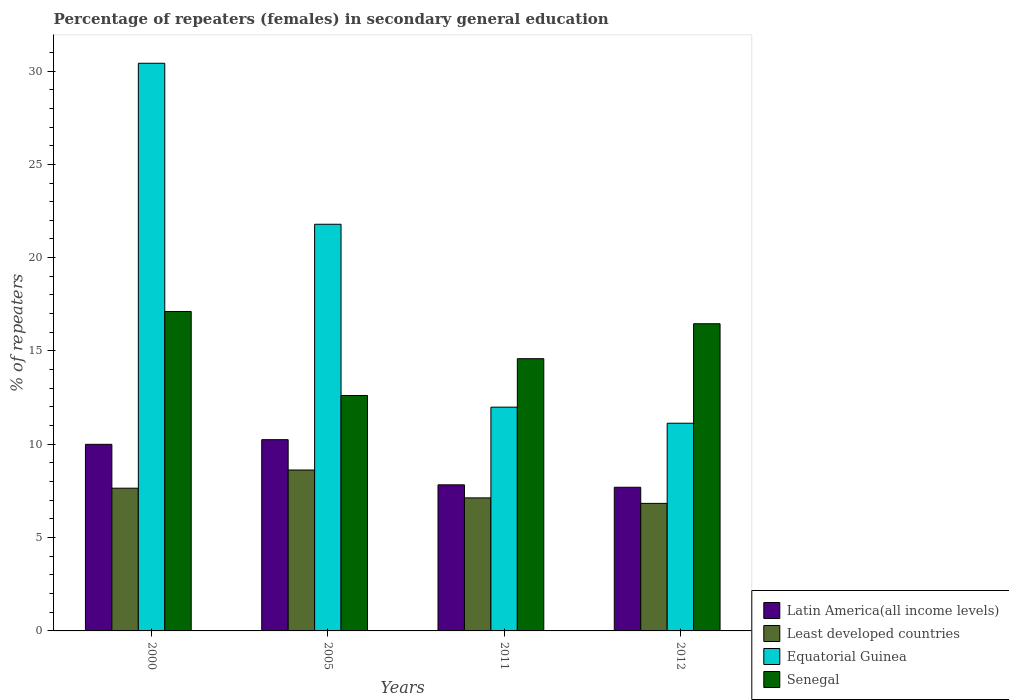How many different coloured bars are there?
Provide a succinct answer. 4. How many groups of bars are there?
Offer a terse response. 4. Are the number of bars per tick equal to the number of legend labels?
Provide a succinct answer. Yes. How many bars are there on the 4th tick from the left?
Your response must be concise. 4. How many bars are there on the 2nd tick from the right?
Your answer should be compact. 4. What is the percentage of female repeaters in Senegal in 2011?
Provide a short and direct response. 14.59. Across all years, what is the maximum percentage of female repeaters in Senegal?
Provide a succinct answer. 17.12. Across all years, what is the minimum percentage of female repeaters in Equatorial Guinea?
Keep it short and to the point. 11.13. In which year was the percentage of female repeaters in Equatorial Guinea maximum?
Make the answer very short. 2000. What is the total percentage of female repeaters in Senegal in the graph?
Make the answer very short. 60.78. What is the difference between the percentage of female repeaters in Senegal in 2005 and that in 2011?
Your answer should be very brief. -1.97. What is the difference between the percentage of female repeaters in Senegal in 2005 and the percentage of female repeaters in Least developed countries in 2012?
Make the answer very short. 5.78. What is the average percentage of female repeaters in Latin America(all income levels) per year?
Your response must be concise. 8.94. In the year 2011, what is the difference between the percentage of female repeaters in Least developed countries and percentage of female repeaters in Equatorial Guinea?
Provide a succinct answer. -4.86. What is the ratio of the percentage of female repeaters in Equatorial Guinea in 2000 to that in 2005?
Your answer should be very brief. 1.4. Is the percentage of female repeaters in Least developed countries in 2000 less than that in 2012?
Offer a terse response. No. What is the difference between the highest and the second highest percentage of female repeaters in Least developed countries?
Make the answer very short. 0.97. What is the difference between the highest and the lowest percentage of female repeaters in Latin America(all income levels)?
Offer a very short reply. 2.55. In how many years, is the percentage of female repeaters in Least developed countries greater than the average percentage of female repeaters in Least developed countries taken over all years?
Provide a short and direct response. 2. What does the 1st bar from the left in 2005 represents?
Offer a very short reply. Latin America(all income levels). What does the 4th bar from the right in 2005 represents?
Your response must be concise. Latin America(all income levels). Is it the case that in every year, the sum of the percentage of female repeaters in Latin America(all income levels) and percentage of female repeaters in Least developed countries is greater than the percentage of female repeaters in Equatorial Guinea?
Provide a succinct answer. No. How many legend labels are there?
Make the answer very short. 4. What is the title of the graph?
Offer a very short reply. Percentage of repeaters (females) in secondary general education. Does "Brazil" appear as one of the legend labels in the graph?
Your response must be concise. No. What is the label or title of the X-axis?
Ensure brevity in your answer.  Years. What is the label or title of the Y-axis?
Your answer should be very brief. % of repeaters. What is the % of repeaters in Latin America(all income levels) in 2000?
Your answer should be very brief. 10. What is the % of repeaters of Least developed countries in 2000?
Your response must be concise. 7.65. What is the % of repeaters of Equatorial Guinea in 2000?
Give a very brief answer. 30.42. What is the % of repeaters in Senegal in 2000?
Offer a terse response. 17.12. What is the % of repeaters of Latin America(all income levels) in 2005?
Offer a terse response. 10.25. What is the % of repeaters of Least developed countries in 2005?
Make the answer very short. 8.62. What is the % of repeaters in Equatorial Guinea in 2005?
Give a very brief answer. 21.79. What is the % of repeaters in Senegal in 2005?
Your response must be concise. 12.61. What is the % of repeaters of Latin America(all income levels) in 2011?
Your response must be concise. 7.83. What is the % of repeaters of Least developed countries in 2011?
Give a very brief answer. 7.13. What is the % of repeaters in Equatorial Guinea in 2011?
Your answer should be compact. 11.99. What is the % of repeaters of Senegal in 2011?
Your response must be concise. 14.59. What is the % of repeaters in Latin America(all income levels) in 2012?
Ensure brevity in your answer.  7.7. What is the % of repeaters in Least developed countries in 2012?
Give a very brief answer. 6.83. What is the % of repeaters in Equatorial Guinea in 2012?
Provide a short and direct response. 11.13. What is the % of repeaters of Senegal in 2012?
Offer a terse response. 16.46. Across all years, what is the maximum % of repeaters in Latin America(all income levels)?
Give a very brief answer. 10.25. Across all years, what is the maximum % of repeaters in Least developed countries?
Offer a terse response. 8.62. Across all years, what is the maximum % of repeaters of Equatorial Guinea?
Provide a short and direct response. 30.42. Across all years, what is the maximum % of repeaters in Senegal?
Make the answer very short. 17.12. Across all years, what is the minimum % of repeaters in Latin America(all income levels)?
Give a very brief answer. 7.7. Across all years, what is the minimum % of repeaters of Least developed countries?
Offer a very short reply. 6.83. Across all years, what is the minimum % of repeaters in Equatorial Guinea?
Your answer should be compact. 11.13. Across all years, what is the minimum % of repeaters of Senegal?
Ensure brevity in your answer.  12.61. What is the total % of repeaters in Latin America(all income levels) in the graph?
Your answer should be compact. 35.77. What is the total % of repeaters of Least developed countries in the graph?
Keep it short and to the point. 30.23. What is the total % of repeaters of Equatorial Guinea in the graph?
Offer a terse response. 75.33. What is the total % of repeaters of Senegal in the graph?
Your answer should be very brief. 60.78. What is the difference between the % of repeaters in Latin America(all income levels) in 2000 and that in 2005?
Ensure brevity in your answer.  -0.25. What is the difference between the % of repeaters in Least developed countries in 2000 and that in 2005?
Provide a short and direct response. -0.97. What is the difference between the % of repeaters in Equatorial Guinea in 2000 and that in 2005?
Offer a very short reply. 8.63. What is the difference between the % of repeaters in Senegal in 2000 and that in 2005?
Make the answer very short. 4.5. What is the difference between the % of repeaters in Latin America(all income levels) in 2000 and that in 2011?
Your answer should be very brief. 2.17. What is the difference between the % of repeaters of Least developed countries in 2000 and that in 2011?
Your answer should be very brief. 0.52. What is the difference between the % of repeaters of Equatorial Guinea in 2000 and that in 2011?
Provide a succinct answer. 18.43. What is the difference between the % of repeaters in Senegal in 2000 and that in 2011?
Your answer should be very brief. 2.53. What is the difference between the % of repeaters of Latin America(all income levels) in 2000 and that in 2012?
Provide a succinct answer. 2.3. What is the difference between the % of repeaters of Least developed countries in 2000 and that in 2012?
Provide a succinct answer. 0.81. What is the difference between the % of repeaters in Equatorial Guinea in 2000 and that in 2012?
Your response must be concise. 19.29. What is the difference between the % of repeaters in Senegal in 2000 and that in 2012?
Keep it short and to the point. 0.66. What is the difference between the % of repeaters of Latin America(all income levels) in 2005 and that in 2011?
Provide a succinct answer. 2.42. What is the difference between the % of repeaters in Least developed countries in 2005 and that in 2011?
Provide a succinct answer. 1.49. What is the difference between the % of repeaters in Equatorial Guinea in 2005 and that in 2011?
Offer a terse response. 9.8. What is the difference between the % of repeaters of Senegal in 2005 and that in 2011?
Offer a very short reply. -1.97. What is the difference between the % of repeaters in Latin America(all income levels) in 2005 and that in 2012?
Provide a succinct answer. 2.55. What is the difference between the % of repeaters of Least developed countries in 2005 and that in 2012?
Your response must be concise. 1.79. What is the difference between the % of repeaters of Equatorial Guinea in 2005 and that in 2012?
Provide a short and direct response. 10.66. What is the difference between the % of repeaters of Senegal in 2005 and that in 2012?
Provide a short and direct response. -3.84. What is the difference between the % of repeaters in Latin America(all income levels) in 2011 and that in 2012?
Your response must be concise. 0.13. What is the difference between the % of repeaters in Least developed countries in 2011 and that in 2012?
Offer a very short reply. 0.29. What is the difference between the % of repeaters in Equatorial Guinea in 2011 and that in 2012?
Offer a very short reply. 0.86. What is the difference between the % of repeaters in Senegal in 2011 and that in 2012?
Offer a very short reply. -1.87. What is the difference between the % of repeaters of Latin America(all income levels) in 2000 and the % of repeaters of Least developed countries in 2005?
Your answer should be very brief. 1.38. What is the difference between the % of repeaters of Latin America(all income levels) in 2000 and the % of repeaters of Equatorial Guinea in 2005?
Your answer should be compact. -11.79. What is the difference between the % of repeaters of Latin America(all income levels) in 2000 and the % of repeaters of Senegal in 2005?
Provide a short and direct response. -2.62. What is the difference between the % of repeaters in Least developed countries in 2000 and the % of repeaters in Equatorial Guinea in 2005?
Provide a short and direct response. -14.14. What is the difference between the % of repeaters in Least developed countries in 2000 and the % of repeaters in Senegal in 2005?
Keep it short and to the point. -4.97. What is the difference between the % of repeaters of Equatorial Guinea in 2000 and the % of repeaters of Senegal in 2005?
Keep it short and to the point. 17.8. What is the difference between the % of repeaters in Latin America(all income levels) in 2000 and the % of repeaters in Least developed countries in 2011?
Make the answer very short. 2.87. What is the difference between the % of repeaters in Latin America(all income levels) in 2000 and the % of repeaters in Equatorial Guinea in 2011?
Offer a very short reply. -1.99. What is the difference between the % of repeaters in Latin America(all income levels) in 2000 and the % of repeaters in Senegal in 2011?
Give a very brief answer. -4.59. What is the difference between the % of repeaters in Least developed countries in 2000 and the % of repeaters in Equatorial Guinea in 2011?
Make the answer very short. -4.34. What is the difference between the % of repeaters of Least developed countries in 2000 and the % of repeaters of Senegal in 2011?
Offer a terse response. -6.94. What is the difference between the % of repeaters in Equatorial Guinea in 2000 and the % of repeaters in Senegal in 2011?
Your answer should be compact. 15.83. What is the difference between the % of repeaters in Latin America(all income levels) in 2000 and the % of repeaters in Least developed countries in 2012?
Make the answer very short. 3.16. What is the difference between the % of repeaters in Latin America(all income levels) in 2000 and the % of repeaters in Equatorial Guinea in 2012?
Offer a very short reply. -1.13. What is the difference between the % of repeaters in Latin America(all income levels) in 2000 and the % of repeaters in Senegal in 2012?
Your response must be concise. -6.46. What is the difference between the % of repeaters of Least developed countries in 2000 and the % of repeaters of Equatorial Guinea in 2012?
Offer a terse response. -3.48. What is the difference between the % of repeaters of Least developed countries in 2000 and the % of repeaters of Senegal in 2012?
Offer a very short reply. -8.81. What is the difference between the % of repeaters of Equatorial Guinea in 2000 and the % of repeaters of Senegal in 2012?
Your answer should be compact. 13.96. What is the difference between the % of repeaters of Latin America(all income levels) in 2005 and the % of repeaters of Least developed countries in 2011?
Make the answer very short. 3.12. What is the difference between the % of repeaters in Latin America(all income levels) in 2005 and the % of repeaters in Equatorial Guinea in 2011?
Your response must be concise. -1.74. What is the difference between the % of repeaters of Latin America(all income levels) in 2005 and the % of repeaters of Senegal in 2011?
Your answer should be compact. -4.34. What is the difference between the % of repeaters in Least developed countries in 2005 and the % of repeaters in Equatorial Guinea in 2011?
Give a very brief answer. -3.37. What is the difference between the % of repeaters in Least developed countries in 2005 and the % of repeaters in Senegal in 2011?
Keep it short and to the point. -5.96. What is the difference between the % of repeaters in Equatorial Guinea in 2005 and the % of repeaters in Senegal in 2011?
Make the answer very short. 7.2. What is the difference between the % of repeaters of Latin America(all income levels) in 2005 and the % of repeaters of Least developed countries in 2012?
Your response must be concise. 3.41. What is the difference between the % of repeaters in Latin America(all income levels) in 2005 and the % of repeaters in Equatorial Guinea in 2012?
Your answer should be very brief. -0.88. What is the difference between the % of repeaters of Latin America(all income levels) in 2005 and the % of repeaters of Senegal in 2012?
Your answer should be very brief. -6.21. What is the difference between the % of repeaters in Least developed countries in 2005 and the % of repeaters in Equatorial Guinea in 2012?
Your answer should be very brief. -2.51. What is the difference between the % of repeaters of Least developed countries in 2005 and the % of repeaters of Senegal in 2012?
Ensure brevity in your answer.  -7.84. What is the difference between the % of repeaters of Equatorial Guinea in 2005 and the % of repeaters of Senegal in 2012?
Keep it short and to the point. 5.33. What is the difference between the % of repeaters of Latin America(all income levels) in 2011 and the % of repeaters of Least developed countries in 2012?
Your answer should be very brief. 0.99. What is the difference between the % of repeaters in Latin America(all income levels) in 2011 and the % of repeaters in Equatorial Guinea in 2012?
Offer a terse response. -3.3. What is the difference between the % of repeaters of Latin America(all income levels) in 2011 and the % of repeaters of Senegal in 2012?
Offer a very short reply. -8.63. What is the difference between the % of repeaters in Least developed countries in 2011 and the % of repeaters in Equatorial Guinea in 2012?
Ensure brevity in your answer.  -4. What is the difference between the % of repeaters in Least developed countries in 2011 and the % of repeaters in Senegal in 2012?
Provide a short and direct response. -9.33. What is the difference between the % of repeaters in Equatorial Guinea in 2011 and the % of repeaters in Senegal in 2012?
Give a very brief answer. -4.47. What is the average % of repeaters in Latin America(all income levels) per year?
Your response must be concise. 8.94. What is the average % of repeaters in Least developed countries per year?
Provide a short and direct response. 7.56. What is the average % of repeaters of Equatorial Guinea per year?
Your answer should be compact. 18.83. What is the average % of repeaters of Senegal per year?
Offer a terse response. 15.19. In the year 2000, what is the difference between the % of repeaters in Latin America(all income levels) and % of repeaters in Least developed countries?
Your response must be concise. 2.35. In the year 2000, what is the difference between the % of repeaters in Latin America(all income levels) and % of repeaters in Equatorial Guinea?
Provide a short and direct response. -20.42. In the year 2000, what is the difference between the % of repeaters in Latin America(all income levels) and % of repeaters in Senegal?
Your answer should be compact. -7.12. In the year 2000, what is the difference between the % of repeaters in Least developed countries and % of repeaters in Equatorial Guinea?
Keep it short and to the point. -22.77. In the year 2000, what is the difference between the % of repeaters in Least developed countries and % of repeaters in Senegal?
Your answer should be very brief. -9.47. In the year 2000, what is the difference between the % of repeaters of Equatorial Guinea and % of repeaters of Senegal?
Your response must be concise. 13.3. In the year 2005, what is the difference between the % of repeaters in Latin America(all income levels) and % of repeaters in Least developed countries?
Provide a succinct answer. 1.62. In the year 2005, what is the difference between the % of repeaters in Latin America(all income levels) and % of repeaters in Equatorial Guinea?
Give a very brief answer. -11.54. In the year 2005, what is the difference between the % of repeaters in Latin America(all income levels) and % of repeaters in Senegal?
Your response must be concise. -2.37. In the year 2005, what is the difference between the % of repeaters of Least developed countries and % of repeaters of Equatorial Guinea?
Give a very brief answer. -13.17. In the year 2005, what is the difference between the % of repeaters of Least developed countries and % of repeaters of Senegal?
Give a very brief answer. -3.99. In the year 2005, what is the difference between the % of repeaters of Equatorial Guinea and % of repeaters of Senegal?
Your answer should be compact. 9.18. In the year 2011, what is the difference between the % of repeaters of Latin America(all income levels) and % of repeaters of Least developed countries?
Offer a terse response. 0.7. In the year 2011, what is the difference between the % of repeaters in Latin America(all income levels) and % of repeaters in Equatorial Guinea?
Ensure brevity in your answer.  -4.16. In the year 2011, what is the difference between the % of repeaters of Latin America(all income levels) and % of repeaters of Senegal?
Offer a very short reply. -6.76. In the year 2011, what is the difference between the % of repeaters of Least developed countries and % of repeaters of Equatorial Guinea?
Your response must be concise. -4.86. In the year 2011, what is the difference between the % of repeaters of Least developed countries and % of repeaters of Senegal?
Offer a very short reply. -7.46. In the year 2011, what is the difference between the % of repeaters in Equatorial Guinea and % of repeaters in Senegal?
Ensure brevity in your answer.  -2.6. In the year 2012, what is the difference between the % of repeaters of Latin America(all income levels) and % of repeaters of Least developed countries?
Make the answer very short. 0.86. In the year 2012, what is the difference between the % of repeaters in Latin America(all income levels) and % of repeaters in Equatorial Guinea?
Ensure brevity in your answer.  -3.43. In the year 2012, what is the difference between the % of repeaters in Latin America(all income levels) and % of repeaters in Senegal?
Provide a short and direct response. -8.76. In the year 2012, what is the difference between the % of repeaters of Least developed countries and % of repeaters of Equatorial Guinea?
Provide a short and direct response. -4.3. In the year 2012, what is the difference between the % of repeaters of Least developed countries and % of repeaters of Senegal?
Your response must be concise. -9.63. In the year 2012, what is the difference between the % of repeaters in Equatorial Guinea and % of repeaters in Senegal?
Your answer should be very brief. -5.33. What is the ratio of the % of repeaters in Latin America(all income levels) in 2000 to that in 2005?
Ensure brevity in your answer.  0.98. What is the ratio of the % of repeaters of Least developed countries in 2000 to that in 2005?
Your answer should be compact. 0.89. What is the ratio of the % of repeaters of Equatorial Guinea in 2000 to that in 2005?
Give a very brief answer. 1.4. What is the ratio of the % of repeaters of Senegal in 2000 to that in 2005?
Offer a very short reply. 1.36. What is the ratio of the % of repeaters of Latin America(all income levels) in 2000 to that in 2011?
Make the answer very short. 1.28. What is the ratio of the % of repeaters of Least developed countries in 2000 to that in 2011?
Give a very brief answer. 1.07. What is the ratio of the % of repeaters of Equatorial Guinea in 2000 to that in 2011?
Make the answer very short. 2.54. What is the ratio of the % of repeaters in Senegal in 2000 to that in 2011?
Give a very brief answer. 1.17. What is the ratio of the % of repeaters in Latin America(all income levels) in 2000 to that in 2012?
Provide a succinct answer. 1.3. What is the ratio of the % of repeaters in Least developed countries in 2000 to that in 2012?
Offer a terse response. 1.12. What is the ratio of the % of repeaters in Equatorial Guinea in 2000 to that in 2012?
Your answer should be very brief. 2.73. What is the ratio of the % of repeaters of Senegal in 2000 to that in 2012?
Give a very brief answer. 1.04. What is the ratio of the % of repeaters of Latin America(all income levels) in 2005 to that in 2011?
Ensure brevity in your answer.  1.31. What is the ratio of the % of repeaters in Least developed countries in 2005 to that in 2011?
Provide a short and direct response. 1.21. What is the ratio of the % of repeaters in Equatorial Guinea in 2005 to that in 2011?
Your response must be concise. 1.82. What is the ratio of the % of repeaters of Senegal in 2005 to that in 2011?
Provide a short and direct response. 0.86. What is the ratio of the % of repeaters of Latin America(all income levels) in 2005 to that in 2012?
Provide a short and direct response. 1.33. What is the ratio of the % of repeaters of Least developed countries in 2005 to that in 2012?
Offer a very short reply. 1.26. What is the ratio of the % of repeaters in Equatorial Guinea in 2005 to that in 2012?
Your answer should be very brief. 1.96. What is the ratio of the % of repeaters of Senegal in 2005 to that in 2012?
Your answer should be very brief. 0.77. What is the ratio of the % of repeaters in Latin America(all income levels) in 2011 to that in 2012?
Provide a short and direct response. 1.02. What is the ratio of the % of repeaters of Least developed countries in 2011 to that in 2012?
Your answer should be very brief. 1.04. What is the ratio of the % of repeaters of Equatorial Guinea in 2011 to that in 2012?
Provide a succinct answer. 1.08. What is the ratio of the % of repeaters of Senegal in 2011 to that in 2012?
Make the answer very short. 0.89. What is the difference between the highest and the second highest % of repeaters of Latin America(all income levels)?
Keep it short and to the point. 0.25. What is the difference between the highest and the second highest % of repeaters in Least developed countries?
Ensure brevity in your answer.  0.97. What is the difference between the highest and the second highest % of repeaters in Equatorial Guinea?
Offer a terse response. 8.63. What is the difference between the highest and the second highest % of repeaters of Senegal?
Your response must be concise. 0.66. What is the difference between the highest and the lowest % of repeaters in Latin America(all income levels)?
Your answer should be very brief. 2.55. What is the difference between the highest and the lowest % of repeaters of Least developed countries?
Provide a short and direct response. 1.79. What is the difference between the highest and the lowest % of repeaters in Equatorial Guinea?
Keep it short and to the point. 19.29. What is the difference between the highest and the lowest % of repeaters of Senegal?
Provide a short and direct response. 4.5. 